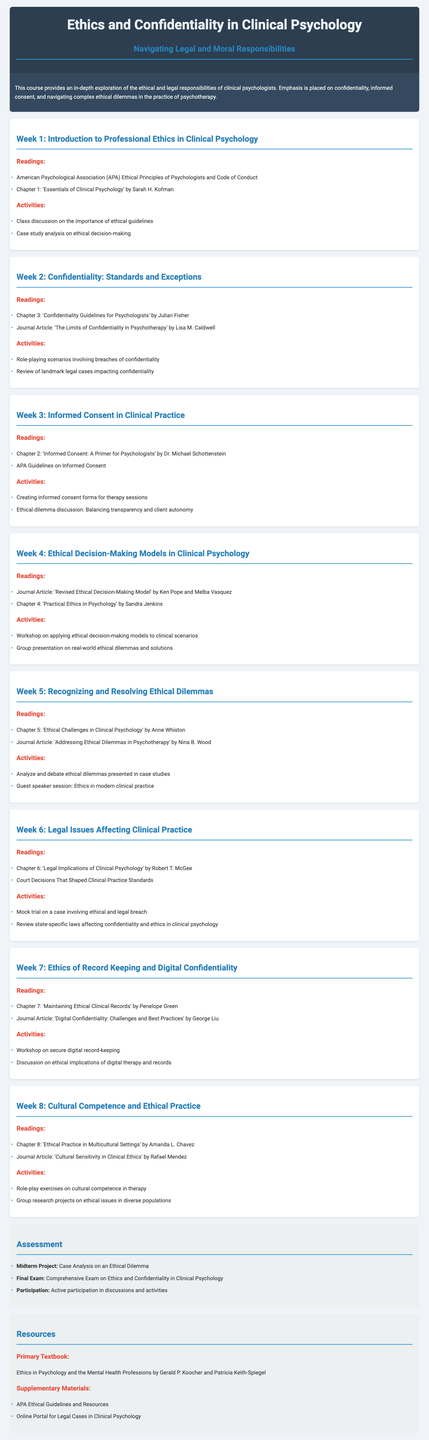What is the title of the course? The title of the course is explicitly stated at the beginning of the syllabus.
Answer: Ethics and Confidentiality in Clinical Psychology What is the main focus of the course? The focus of the course is mentioned in the course description section, highlighting key topics the course will cover.
Answer: Ethical and legal responsibilities Who authored the textbook used for the course? The primary textbook is stated in the resources section, including the authors' names.
Answer: Gerald P. Koocher and Patricia Keith-Spiegel Which week covers the topic of Informed Consent? The weeks are numbered and alligned with specific topics in the syllabus, allowing us to identify the week for a specific topic.
Answer: Week 3 What activity is included in Week 2? The activities section lists various activities for each week, providing clear details for Week 2.
Answer: Role-playing scenarios involving breaches of confidentiality How many weeks are included in the syllabus? The number of weeks is identified by counting the distinct weekly sections outlined in the document.
Answer: 8 What does the midterm project focus on? The assessment section describes the content and goals of the midterm project, which is directly stated.
Answer: Case Analysis on an Ethical Dilemma Which chapter discusses digital confidentiality challenges? The readings for the week related to digital confidentiality specify the chapter discussing relevant challenges.
Answer: Chapter 7: 'Maintaining Ethical Clinical Records' 